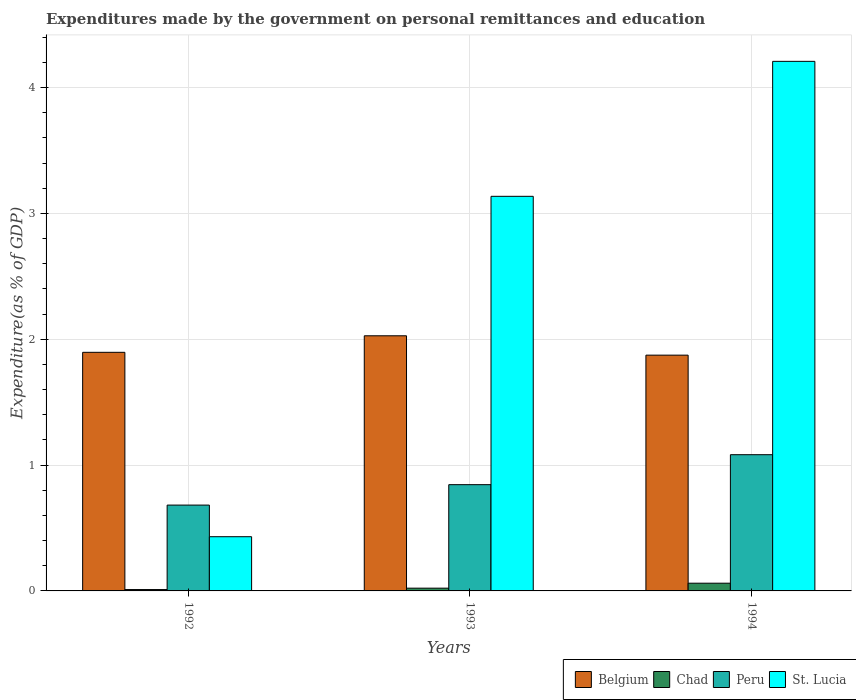How many different coloured bars are there?
Your answer should be very brief. 4. How many groups of bars are there?
Provide a short and direct response. 3. Are the number of bars per tick equal to the number of legend labels?
Offer a terse response. Yes. How many bars are there on the 3rd tick from the left?
Give a very brief answer. 4. How many bars are there on the 3rd tick from the right?
Make the answer very short. 4. In how many cases, is the number of bars for a given year not equal to the number of legend labels?
Your answer should be very brief. 0. What is the expenditures made by the government on personal remittances and education in Peru in 1994?
Your answer should be compact. 1.08. Across all years, what is the maximum expenditures made by the government on personal remittances and education in Peru?
Provide a succinct answer. 1.08. Across all years, what is the minimum expenditures made by the government on personal remittances and education in Belgium?
Offer a very short reply. 1.87. In which year was the expenditures made by the government on personal remittances and education in Belgium maximum?
Provide a succinct answer. 1993. In which year was the expenditures made by the government on personal remittances and education in Chad minimum?
Your response must be concise. 1992. What is the total expenditures made by the government on personal remittances and education in Peru in the graph?
Provide a succinct answer. 2.61. What is the difference between the expenditures made by the government on personal remittances and education in Belgium in 1993 and that in 1994?
Offer a very short reply. 0.15. What is the difference between the expenditures made by the government on personal remittances and education in Belgium in 1993 and the expenditures made by the government on personal remittances and education in Peru in 1994?
Offer a very short reply. 0.94. What is the average expenditures made by the government on personal remittances and education in Belgium per year?
Offer a terse response. 1.93. In the year 1993, what is the difference between the expenditures made by the government on personal remittances and education in Belgium and expenditures made by the government on personal remittances and education in Peru?
Your answer should be compact. 1.18. What is the ratio of the expenditures made by the government on personal remittances and education in St. Lucia in 1993 to that in 1994?
Your answer should be very brief. 0.75. What is the difference between the highest and the second highest expenditures made by the government on personal remittances and education in St. Lucia?
Your answer should be compact. 1.07. What is the difference between the highest and the lowest expenditures made by the government on personal remittances and education in Peru?
Your answer should be very brief. 0.4. Is the sum of the expenditures made by the government on personal remittances and education in Chad in 1993 and 1994 greater than the maximum expenditures made by the government on personal remittances and education in Belgium across all years?
Make the answer very short. No. What does the 3rd bar from the left in 1993 represents?
Give a very brief answer. Peru. What does the 3rd bar from the right in 1994 represents?
Ensure brevity in your answer.  Chad. How many bars are there?
Provide a succinct answer. 12. How many years are there in the graph?
Ensure brevity in your answer.  3. Are the values on the major ticks of Y-axis written in scientific E-notation?
Provide a short and direct response. No. Where does the legend appear in the graph?
Your response must be concise. Bottom right. What is the title of the graph?
Give a very brief answer. Expenditures made by the government on personal remittances and education. Does "Lao PDR" appear as one of the legend labels in the graph?
Provide a short and direct response. No. What is the label or title of the X-axis?
Your answer should be compact. Years. What is the label or title of the Y-axis?
Provide a succinct answer. Expenditure(as % of GDP). What is the Expenditure(as % of GDP) in Belgium in 1992?
Make the answer very short. 1.9. What is the Expenditure(as % of GDP) in Chad in 1992?
Give a very brief answer. 0.01. What is the Expenditure(as % of GDP) in Peru in 1992?
Make the answer very short. 0.68. What is the Expenditure(as % of GDP) in St. Lucia in 1992?
Offer a very short reply. 0.43. What is the Expenditure(as % of GDP) of Belgium in 1993?
Provide a succinct answer. 2.03. What is the Expenditure(as % of GDP) in Chad in 1993?
Make the answer very short. 0.02. What is the Expenditure(as % of GDP) of Peru in 1993?
Make the answer very short. 0.84. What is the Expenditure(as % of GDP) of St. Lucia in 1993?
Offer a very short reply. 3.14. What is the Expenditure(as % of GDP) in Belgium in 1994?
Provide a short and direct response. 1.87. What is the Expenditure(as % of GDP) of Chad in 1994?
Ensure brevity in your answer.  0.06. What is the Expenditure(as % of GDP) of Peru in 1994?
Give a very brief answer. 1.08. What is the Expenditure(as % of GDP) in St. Lucia in 1994?
Give a very brief answer. 4.21. Across all years, what is the maximum Expenditure(as % of GDP) of Belgium?
Make the answer very short. 2.03. Across all years, what is the maximum Expenditure(as % of GDP) of Chad?
Keep it short and to the point. 0.06. Across all years, what is the maximum Expenditure(as % of GDP) in Peru?
Your response must be concise. 1.08. Across all years, what is the maximum Expenditure(as % of GDP) in St. Lucia?
Offer a terse response. 4.21. Across all years, what is the minimum Expenditure(as % of GDP) of Belgium?
Offer a terse response. 1.87. Across all years, what is the minimum Expenditure(as % of GDP) of Chad?
Your answer should be compact. 0.01. Across all years, what is the minimum Expenditure(as % of GDP) of Peru?
Your response must be concise. 0.68. Across all years, what is the minimum Expenditure(as % of GDP) in St. Lucia?
Provide a succinct answer. 0.43. What is the total Expenditure(as % of GDP) in Belgium in the graph?
Your answer should be very brief. 5.8. What is the total Expenditure(as % of GDP) in Chad in the graph?
Your answer should be compact. 0.09. What is the total Expenditure(as % of GDP) of Peru in the graph?
Ensure brevity in your answer.  2.61. What is the total Expenditure(as % of GDP) in St. Lucia in the graph?
Make the answer very short. 7.78. What is the difference between the Expenditure(as % of GDP) of Belgium in 1992 and that in 1993?
Offer a terse response. -0.13. What is the difference between the Expenditure(as % of GDP) in Chad in 1992 and that in 1993?
Ensure brevity in your answer.  -0.01. What is the difference between the Expenditure(as % of GDP) of Peru in 1992 and that in 1993?
Provide a short and direct response. -0.16. What is the difference between the Expenditure(as % of GDP) of St. Lucia in 1992 and that in 1993?
Offer a very short reply. -2.71. What is the difference between the Expenditure(as % of GDP) of Belgium in 1992 and that in 1994?
Provide a succinct answer. 0.02. What is the difference between the Expenditure(as % of GDP) of Chad in 1992 and that in 1994?
Offer a terse response. -0.05. What is the difference between the Expenditure(as % of GDP) in Peru in 1992 and that in 1994?
Provide a short and direct response. -0.4. What is the difference between the Expenditure(as % of GDP) in St. Lucia in 1992 and that in 1994?
Provide a short and direct response. -3.78. What is the difference between the Expenditure(as % of GDP) in Belgium in 1993 and that in 1994?
Your answer should be compact. 0.15. What is the difference between the Expenditure(as % of GDP) of Chad in 1993 and that in 1994?
Ensure brevity in your answer.  -0.04. What is the difference between the Expenditure(as % of GDP) of Peru in 1993 and that in 1994?
Offer a very short reply. -0.24. What is the difference between the Expenditure(as % of GDP) of St. Lucia in 1993 and that in 1994?
Provide a short and direct response. -1.07. What is the difference between the Expenditure(as % of GDP) of Belgium in 1992 and the Expenditure(as % of GDP) of Chad in 1993?
Make the answer very short. 1.87. What is the difference between the Expenditure(as % of GDP) of Belgium in 1992 and the Expenditure(as % of GDP) of Peru in 1993?
Your answer should be very brief. 1.05. What is the difference between the Expenditure(as % of GDP) in Belgium in 1992 and the Expenditure(as % of GDP) in St. Lucia in 1993?
Your answer should be compact. -1.24. What is the difference between the Expenditure(as % of GDP) of Chad in 1992 and the Expenditure(as % of GDP) of Peru in 1993?
Offer a terse response. -0.83. What is the difference between the Expenditure(as % of GDP) in Chad in 1992 and the Expenditure(as % of GDP) in St. Lucia in 1993?
Your answer should be compact. -3.13. What is the difference between the Expenditure(as % of GDP) of Peru in 1992 and the Expenditure(as % of GDP) of St. Lucia in 1993?
Your response must be concise. -2.45. What is the difference between the Expenditure(as % of GDP) in Belgium in 1992 and the Expenditure(as % of GDP) in Chad in 1994?
Your answer should be very brief. 1.83. What is the difference between the Expenditure(as % of GDP) in Belgium in 1992 and the Expenditure(as % of GDP) in Peru in 1994?
Provide a short and direct response. 0.81. What is the difference between the Expenditure(as % of GDP) of Belgium in 1992 and the Expenditure(as % of GDP) of St. Lucia in 1994?
Offer a terse response. -2.31. What is the difference between the Expenditure(as % of GDP) of Chad in 1992 and the Expenditure(as % of GDP) of Peru in 1994?
Provide a short and direct response. -1.07. What is the difference between the Expenditure(as % of GDP) in Chad in 1992 and the Expenditure(as % of GDP) in St. Lucia in 1994?
Your answer should be very brief. -4.2. What is the difference between the Expenditure(as % of GDP) in Peru in 1992 and the Expenditure(as % of GDP) in St. Lucia in 1994?
Offer a very short reply. -3.53. What is the difference between the Expenditure(as % of GDP) of Belgium in 1993 and the Expenditure(as % of GDP) of Chad in 1994?
Ensure brevity in your answer.  1.97. What is the difference between the Expenditure(as % of GDP) of Belgium in 1993 and the Expenditure(as % of GDP) of Peru in 1994?
Your answer should be compact. 0.94. What is the difference between the Expenditure(as % of GDP) of Belgium in 1993 and the Expenditure(as % of GDP) of St. Lucia in 1994?
Provide a short and direct response. -2.18. What is the difference between the Expenditure(as % of GDP) in Chad in 1993 and the Expenditure(as % of GDP) in Peru in 1994?
Keep it short and to the point. -1.06. What is the difference between the Expenditure(as % of GDP) in Chad in 1993 and the Expenditure(as % of GDP) in St. Lucia in 1994?
Your answer should be very brief. -4.19. What is the difference between the Expenditure(as % of GDP) of Peru in 1993 and the Expenditure(as % of GDP) of St. Lucia in 1994?
Offer a terse response. -3.36. What is the average Expenditure(as % of GDP) in Belgium per year?
Keep it short and to the point. 1.93. What is the average Expenditure(as % of GDP) of Chad per year?
Give a very brief answer. 0.03. What is the average Expenditure(as % of GDP) in Peru per year?
Keep it short and to the point. 0.87. What is the average Expenditure(as % of GDP) of St. Lucia per year?
Offer a very short reply. 2.59. In the year 1992, what is the difference between the Expenditure(as % of GDP) of Belgium and Expenditure(as % of GDP) of Chad?
Provide a succinct answer. 1.89. In the year 1992, what is the difference between the Expenditure(as % of GDP) of Belgium and Expenditure(as % of GDP) of Peru?
Make the answer very short. 1.21. In the year 1992, what is the difference between the Expenditure(as % of GDP) in Belgium and Expenditure(as % of GDP) in St. Lucia?
Make the answer very short. 1.47. In the year 1992, what is the difference between the Expenditure(as % of GDP) in Chad and Expenditure(as % of GDP) in Peru?
Offer a terse response. -0.67. In the year 1992, what is the difference between the Expenditure(as % of GDP) in Chad and Expenditure(as % of GDP) in St. Lucia?
Keep it short and to the point. -0.42. In the year 1992, what is the difference between the Expenditure(as % of GDP) in Peru and Expenditure(as % of GDP) in St. Lucia?
Offer a terse response. 0.25. In the year 1993, what is the difference between the Expenditure(as % of GDP) of Belgium and Expenditure(as % of GDP) of Chad?
Give a very brief answer. 2.01. In the year 1993, what is the difference between the Expenditure(as % of GDP) of Belgium and Expenditure(as % of GDP) of Peru?
Your response must be concise. 1.18. In the year 1993, what is the difference between the Expenditure(as % of GDP) of Belgium and Expenditure(as % of GDP) of St. Lucia?
Provide a succinct answer. -1.11. In the year 1993, what is the difference between the Expenditure(as % of GDP) in Chad and Expenditure(as % of GDP) in Peru?
Your response must be concise. -0.82. In the year 1993, what is the difference between the Expenditure(as % of GDP) in Chad and Expenditure(as % of GDP) in St. Lucia?
Ensure brevity in your answer.  -3.11. In the year 1993, what is the difference between the Expenditure(as % of GDP) in Peru and Expenditure(as % of GDP) in St. Lucia?
Provide a succinct answer. -2.29. In the year 1994, what is the difference between the Expenditure(as % of GDP) in Belgium and Expenditure(as % of GDP) in Chad?
Keep it short and to the point. 1.81. In the year 1994, what is the difference between the Expenditure(as % of GDP) in Belgium and Expenditure(as % of GDP) in Peru?
Give a very brief answer. 0.79. In the year 1994, what is the difference between the Expenditure(as % of GDP) in Belgium and Expenditure(as % of GDP) in St. Lucia?
Offer a terse response. -2.33. In the year 1994, what is the difference between the Expenditure(as % of GDP) of Chad and Expenditure(as % of GDP) of Peru?
Your answer should be very brief. -1.02. In the year 1994, what is the difference between the Expenditure(as % of GDP) of Chad and Expenditure(as % of GDP) of St. Lucia?
Ensure brevity in your answer.  -4.15. In the year 1994, what is the difference between the Expenditure(as % of GDP) of Peru and Expenditure(as % of GDP) of St. Lucia?
Your answer should be compact. -3.13. What is the ratio of the Expenditure(as % of GDP) in Belgium in 1992 to that in 1993?
Ensure brevity in your answer.  0.94. What is the ratio of the Expenditure(as % of GDP) in Chad in 1992 to that in 1993?
Keep it short and to the point. 0.49. What is the ratio of the Expenditure(as % of GDP) in Peru in 1992 to that in 1993?
Give a very brief answer. 0.81. What is the ratio of the Expenditure(as % of GDP) in St. Lucia in 1992 to that in 1993?
Give a very brief answer. 0.14. What is the ratio of the Expenditure(as % of GDP) in Chad in 1992 to that in 1994?
Keep it short and to the point. 0.18. What is the ratio of the Expenditure(as % of GDP) of Peru in 1992 to that in 1994?
Your answer should be compact. 0.63. What is the ratio of the Expenditure(as % of GDP) in St. Lucia in 1992 to that in 1994?
Make the answer very short. 0.1. What is the ratio of the Expenditure(as % of GDP) of Belgium in 1993 to that in 1994?
Your answer should be compact. 1.08. What is the ratio of the Expenditure(as % of GDP) in Chad in 1993 to that in 1994?
Your response must be concise. 0.36. What is the ratio of the Expenditure(as % of GDP) in Peru in 1993 to that in 1994?
Keep it short and to the point. 0.78. What is the ratio of the Expenditure(as % of GDP) of St. Lucia in 1993 to that in 1994?
Provide a short and direct response. 0.75. What is the difference between the highest and the second highest Expenditure(as % of GDP) of Belgium?
Provide a succinct answer. 0.13. What is the difference between the highest and the second highest Expenditure(as % of GDP) in Chad?
Ensure brevity in your answer.  0.04. What is the difference between the highest and the second highest Expenditure(as % of GDP) of Peru?
Your answer should be compact. 0.24. What is the difference between the highest and the second highest Expenditure(as % of GDP) in St. Lucia?
Ensure brevity in your answer.  1.07. What is the difference between the highest and the lowest Expenditure(as % of GDP) in Belgium?
Give a very brief answer. 0.15. What is the difference between the highest and the lowest Expenditure(as % of GDP) of Chad?
Your answer should be very brief. 0.05. What is the difference between the highest and the lowest Expenditure(as % of GDP) of Peru?
Your answer should be very brief. 0.4. What is the difference between the highest and the lowest Expenditure(as % of GDP) of St. Lucia?
Ensure brevity in your answer.  3.78. 